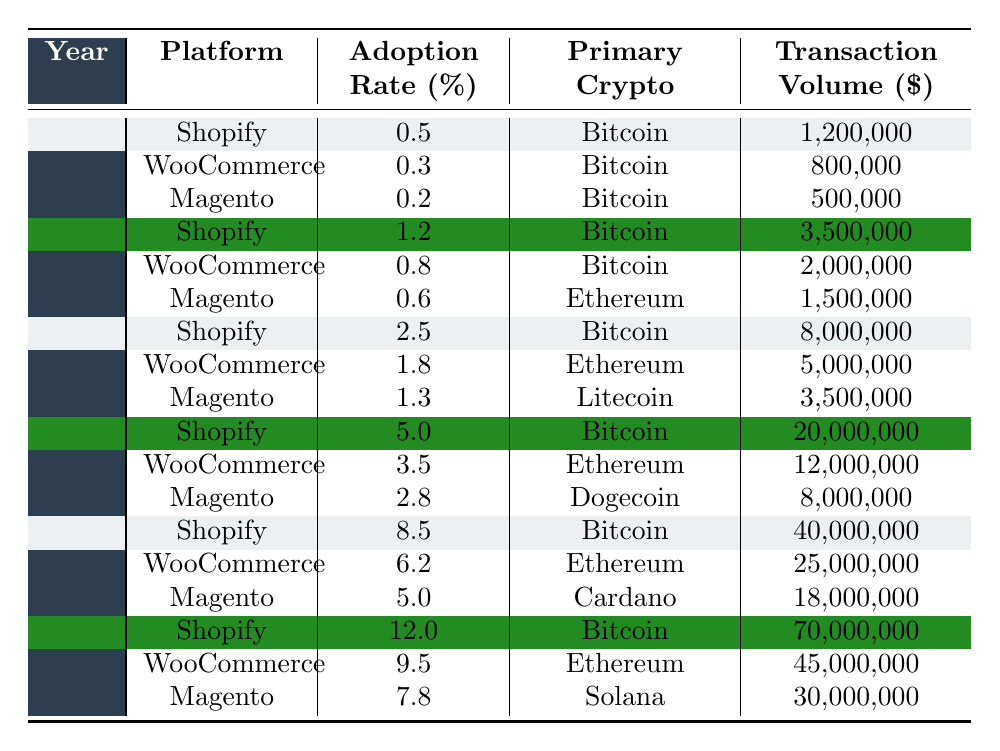What was the adoption rate for Shopify in 2020? In the table, for the year 2020 under the Shopify row, the adoption rate is listed as 2.5%.
Answer: 2.5% Which platform had the highest transaction volume in 2021? In 2021, the transaction volumes for Shopify, WooCommerce, and Magento were 20,000,000, 12,000,000, and 8,000,000 respectively. The highest is Shopify with 20,000,000.
Answer: Shopify What was the primary cryptocurrency used by Magento in 2022? In the year 2022, the primary cryptocurrency for Magento is listed as Cardano.
Answer: Cardano How much did WooCommerce's adoption rate increase from 2018 to 2023? The adoption rates for WooCommerce in 2018 and 2023 were 0.3% and 9.5%, respectively. The increase is calculated as 9.5 - 0.3 = 9.2%.
Answer: 9.2% What is the average adoption rate for Magento from 2018 to 2023? The adoption rates for Magento over these years are 0.2%, 0.6%, 1.3%, 2.8%, 5.0%, and 7.8%, which sum to 17.7%. There are 6 data points, so the average is 17.7 / 6 = 2.95%.
Answer: 2.95% Is it true that Shopify consistently used Bitcoin as its primary cryptocurrency from 2018 to 2023? Reviewing the table reveals that Shopify's primary cryptocurrency remained Bitcoin for all years shown (2018 to 2023).
Answer: Yes Which platform saw the largest year-on-year increase in adoption rate from 2021 to 2022? For 2021, Shopify had an adoption rate of 5.0%, and in 2022 it increased to 8.5%, a change of 3.5%. WooCommerce went from 3.5% to 6.2%, a change of 2.7%. The largest increase belongs to Shopify.
Answer: Shopify What was the total transaction volume for WooCommerce from 2018 to 2023? The transaction volumes for WooCommerce are 800,000, 2,000,000, 5,000,000, 12,000,000, 25,000,000, and 45,000,000 for the years 2018 to 2023. Summing these gives a total of 800,000 + 2,000,000 + 5,000,000 + 12,000,000 + 25,000,000 + 45,000,000 = 89,800,000.
Answer: 89,800,000 In which year did Magento first adopt Ethereum, and what was its adoption rate? Magento first adopted Ethereum in 2019 with an adoption rate of 0.6%.
Answer: 2019, 0.6% Did the transaction volume for Shopify increase more than double from 2021 to 2022? The transaction volume for Shopify in 2021 was 20,000,000, which increased to 40,000,000 in 2022. Doubling 20,000,000 leads to 40,000,000, which means the volume did double but did not exceed it.
Answer: No 